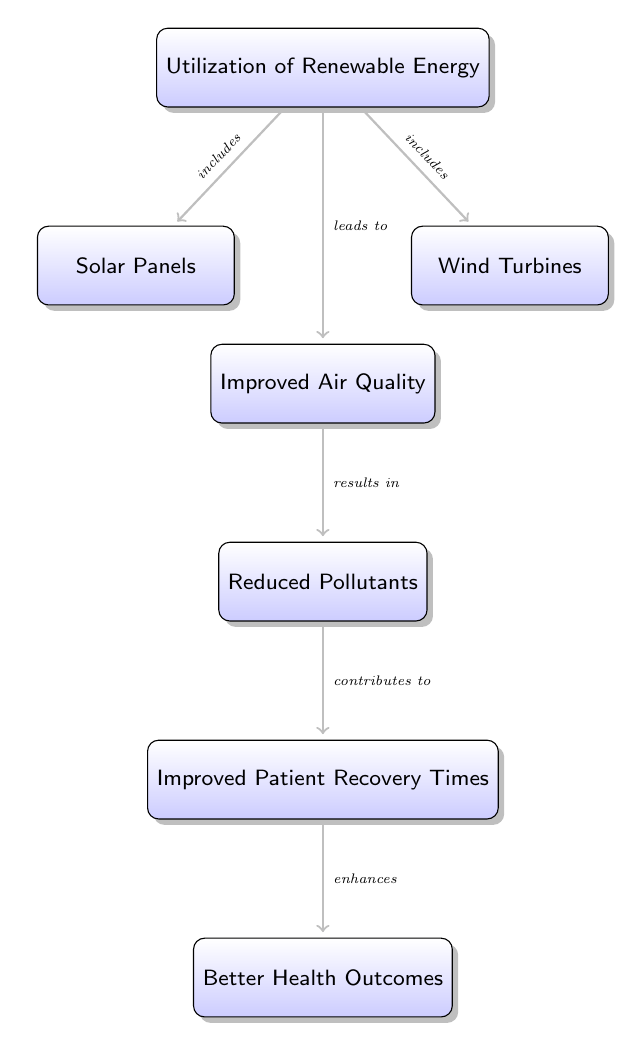What is the first node in the flowchart? The first node in the flowchart is labeled "Utilization of Renewable Energy." It appears at the top of the diagram, indicating the starting point of the flow.
Answer: Utilization of Renewable Energy How many types of renewable energy are indicated in the diagram? The diagram indicates two types of renewable energy: "Solar Panels" and "Wind Turbines." They are represented as nodes branching from the main renewable energy node.
Answer: 2 What is the relationship between improved air quality and reduced pollutants? The relationship is that "Improved Air Quality" results in "Reduced Pollutants." This is shown by the arrow connecting these two nodes, indicating a cause-effect relationship.
Answer: results in What effect does reduced pollutants have on patient recovery time? "Reduced Pollutants" contributes to "Improved Patient Recovery Times." The diagram shows this through an arrow, demonstrating how this factor influences recovery times positively.
Answer: contributes to What is the final outcome shown in the flowchart? The final outcome shown in the flowchart is "Better Health Outcomes." It is the last node at the bottom of the diagram that is reached after following the flow from the renewable energy utilization.
Answer: Better Health Outcomes How does the utilization of renewable energy impact patient recovery times? The utilization of renewable energy leads to improved air quality, which subsequently reduces pollutants, and this reduction contributes to improved patient recovery times. The flow of the diagram illustrates this chain of causation clearly.
Answer: Leads to improved recovery times What kind of diagram is being represented here? This is a textual flowchart that illustrates the relationships and impacts of renewable energy utilization on health outcomes in hospitals. It uses arrows to indicate the direction of influence or causation among the various nodes.
Answer: Textbook Diagram What precedes the "Improved Air Quality" node in the diagram? The node that precedes "Improved Air Quality" is "Utilization of Renewable Energy." The arrow shows that the use of renewable energy directly leads to improvements in air quality.
Answer: Utilization of Renewable Energy What type of energy is represented by the node on the left side of the renewable energy node? The node on the left side of the renewable energy node represents "Solar Panels." It indicates one of the sources of renewable energy utilized in the healthcare context.
Answer: Solar Panels 